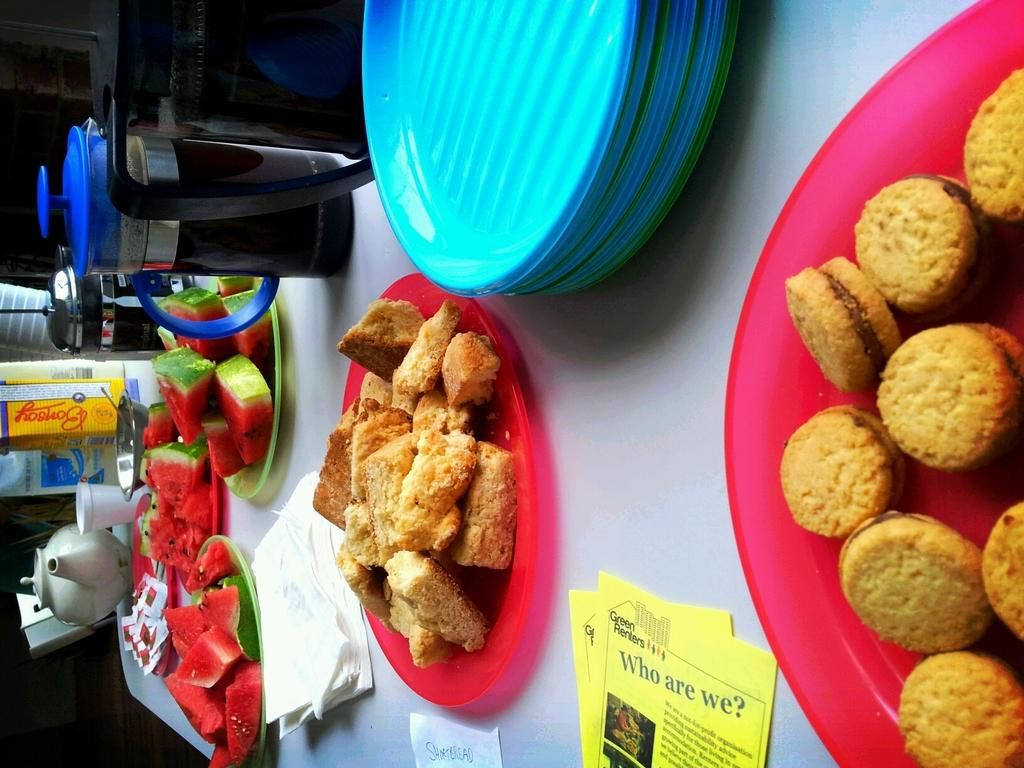What type of food items can be seen on the table in the image? There are cookies, fruits, and bread pieces visible on the table in the image. What other items are present on the table besides food? Platters, tissues, posters, sachets, a cup, a bowl, and jars are present on the table. How many different types of containers are on the table? There are at least four different types of containers on the table: a cup, a bowl, jars, and platters. What type of office equipment can be seen on the table in the image? There is no office equipment present on the table in the image. What type of vacation destination is visible in the image? There is no vacation destination visible in the image; it is a table with various items on it. 